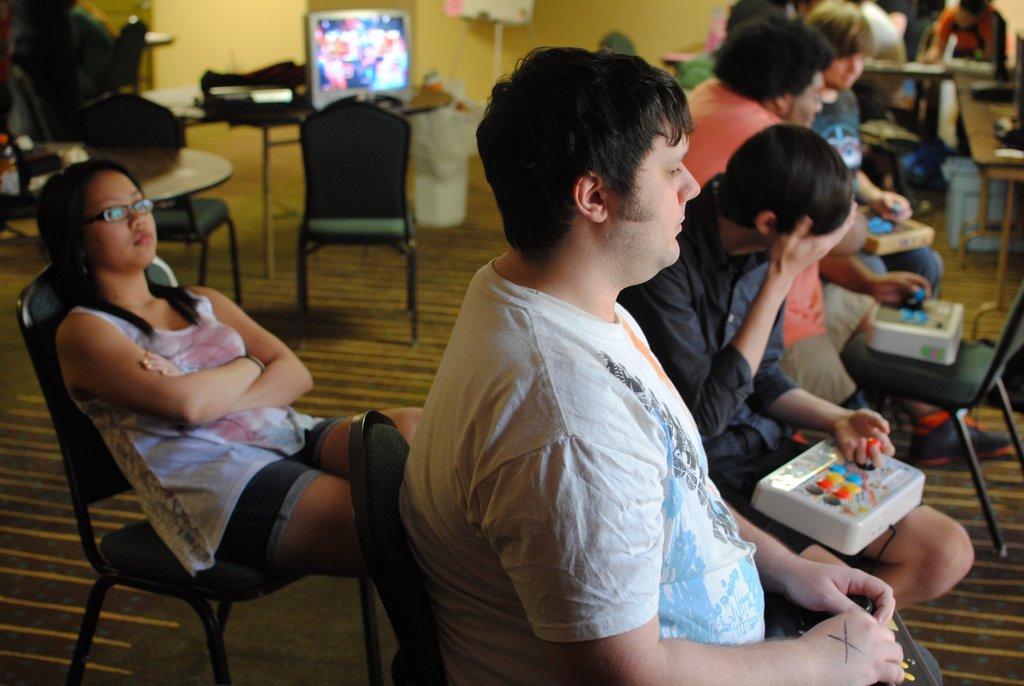Could you give a brief overview of what you see in this image? This image is clicked in a room where there are so many chairs and table. People are sitting on the chair. There is television on the top. There is a table on the left side. 